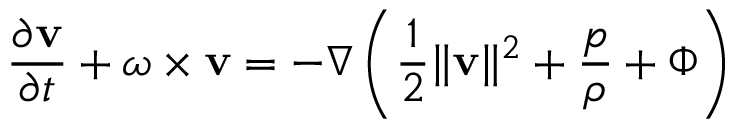Convert formula to latex. <formula><loc_0><loc_0><loc_500><loc_500>{ \frac { \partial { v } } { \partial t } } + \omega \times { v } = - \nabla \left ( { \frac { 1 } { 2 } } \| { v } \| ^ { 2 } + { \frac { p } { \rho } } + \Phi \right )</formula> 